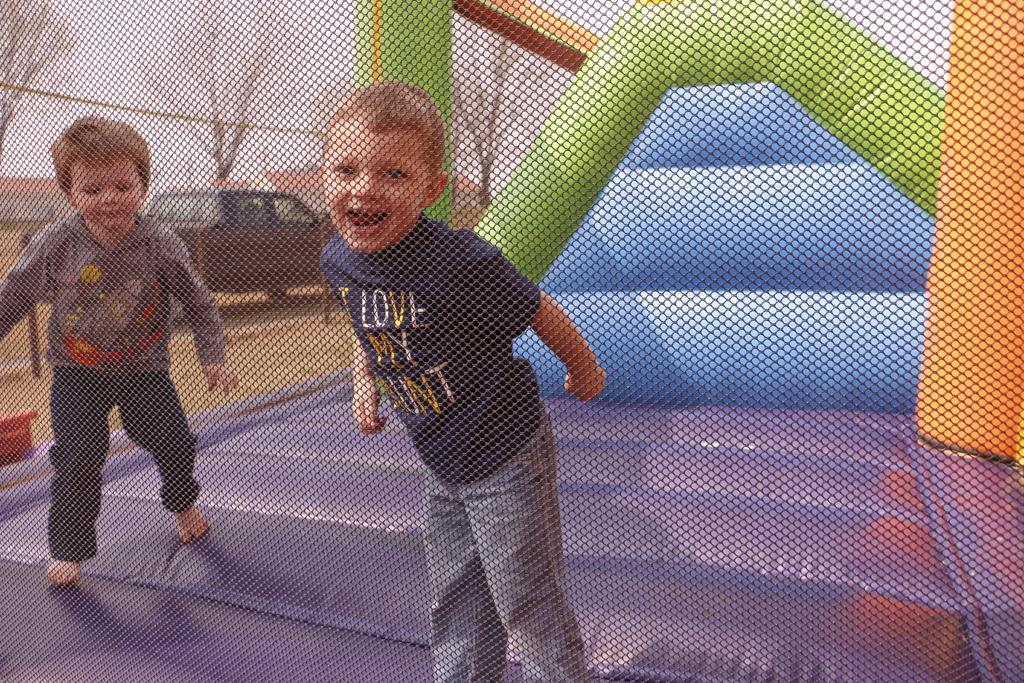What are the two kids doing in the image? The two kids are on an inflatable bouncing in the image. What type of natural elements can be seen in the image? There are trees in the image. What structures are present in the image? There are poles and buildings in the image. What type of transportation is visible in the image? There is a vehicle in the image. What is visible in the background of the image? The sky is visible in the background of the image. Can you tell me how many volleyballs are being played with in the image? There are no volleyballs present in the image. What type of cub is sitting on the inflatable with the kids? There is no cub present in the image; it features two kids on an inflatable bouncing. 